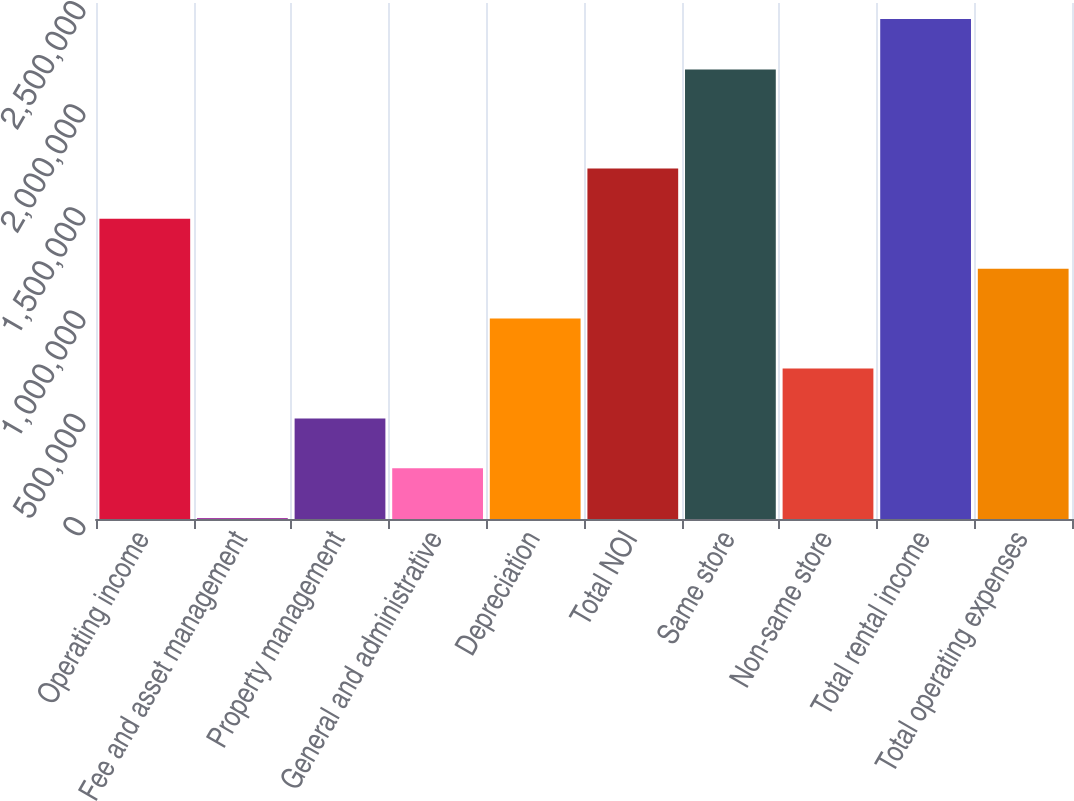<chart> <loc_0><loc_0><loc_500><loc_500><bar_chart><fcel>Operating income<fcel>Fee and asset management<fcel>Property management<fcel>General and administrative<fcel>Depreciation<fcel>Total NOI<fcel>Same store<fcel>Non-same store<fcel>Total rental income<fcel>Total operating expenses<nl><fcel>1.45477e+06<fcel>3567<fcel>487300<fcel>245434<fcel>971033<fcel>1.69802e+06<fcel>2.1773e+06<fcel>729167<fcel>2.42223e+06<fcel>1.2129e+06<nl></chart> 